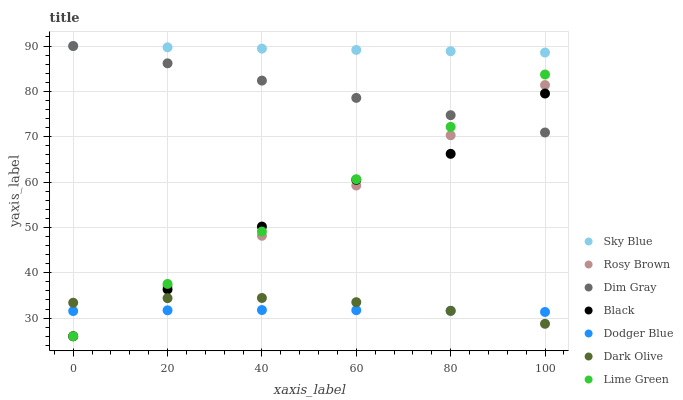Does Dodger Blue have the minimum area under the curve?
Answer yes or no. Yes. Does Sky Blue have the maximum area under the curve?
Answer yes or no. Yes. Does Dark Olive have the minimum area under the curve?
Answer yes or no. No. Does Dark Olive have the maximum area under the curve?
Answer yes or no. No. Is Sky Blue the smoothest?
Answer yes or no. Yes. Is Black the roughest?
Answer yes or no. Yes. Is Dark Olive the smoothest?
Answer yes or no. No. Is Dark Olive the roughest?
Answer yes or no. No. Does Black have the lowest value?
Answer yes or no. Yes. Does Dark Olive have the lowest value?
Answer yes or no. No. Does Sky Blue have the highest value?
Answer yes or no. Yes. Does Dark Olive have the highest value?
Answer yes or no. No. Is Rosy Brown less than Sky Blue?
Answer yes or no. Yes. Is Sky Blue greater than Rosy Brown?
Answer yes or no. Yes. Does Black intersect Rosy Brown?
Answer yes or no. Yes. Is Black less than Rosy Brown?
Answer yes or no. No. Is Black greater than Rosy Brown?
Answer yes or no. No. Does Rosy Brown intersect Sky Blue?
Answer yes or no. No. 